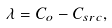<formula> <loc_0><loc_0><loc_500><loc_500>\lambda = C _ { o } - C _ { s r c } ,</formula> 